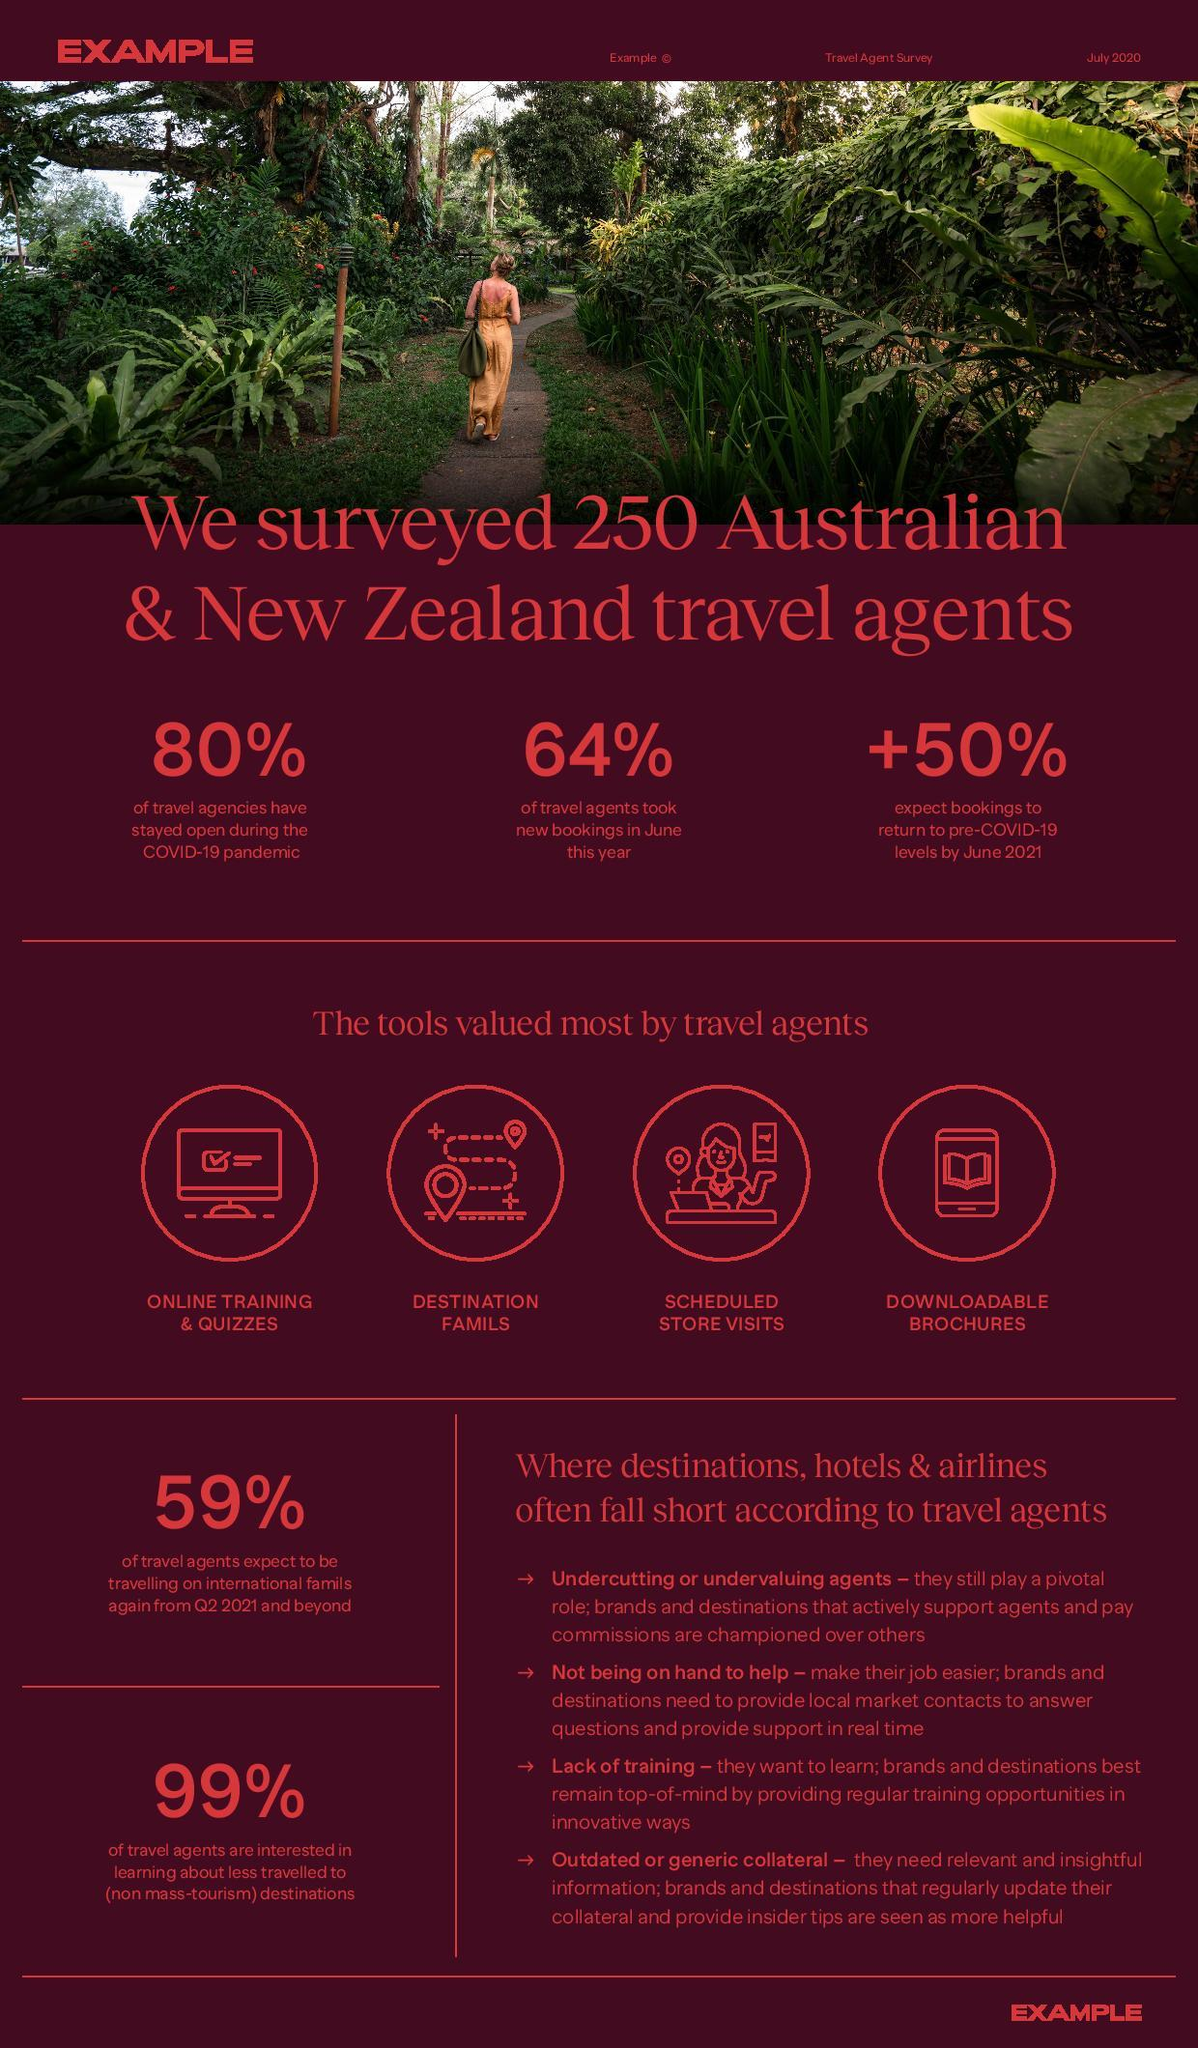Specify some key components in this picture. According to a survey, approximately 20% of travel agencies in Australia and New Zealand did not remain open during the COVID-19 pandemic. According to the survey, 64% of Australian and New Zealand travel agents took on new bookings in June this year. According to the survey, only 1% of Australian and New Zealand travel agents expressed no interest in learning about lesser-known travel destinations. According to the survey, it is expected that bookings will increase by approximately 50% in order to return to pre-COVID-19 levels by June 2021. 